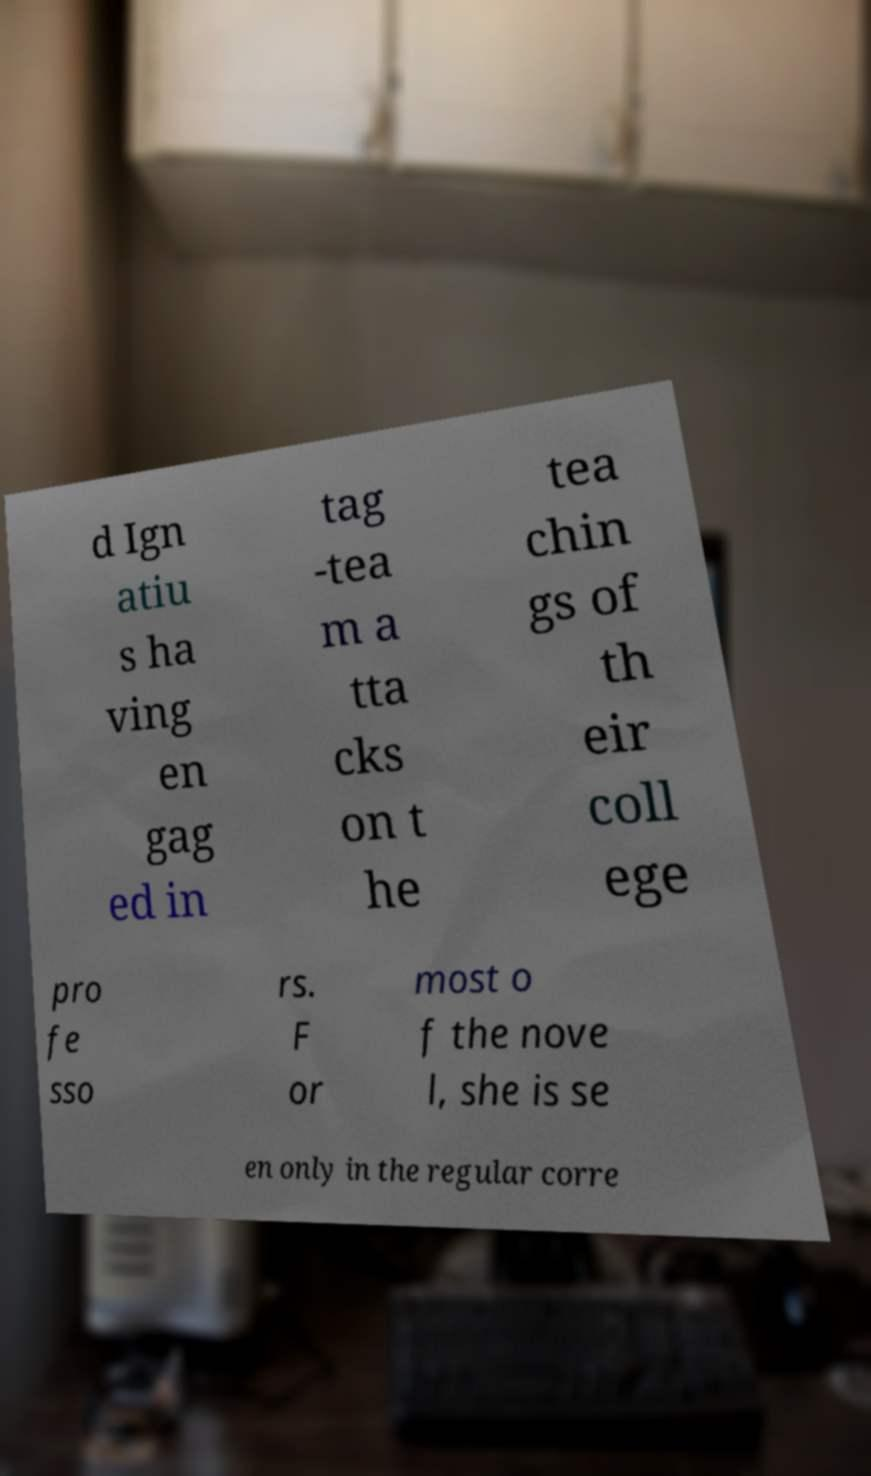Can you read and provide the text displayed in the image?This photo seems to have some interesting text. Can you extract and type it out for me? d Ign atiu s ha ving en gag ed in tag -tea m a tta cks on t he tea chin gs of th eir coll ege pro fe sso rs. F or most o f the nove l, she is se en only in the regular corre 